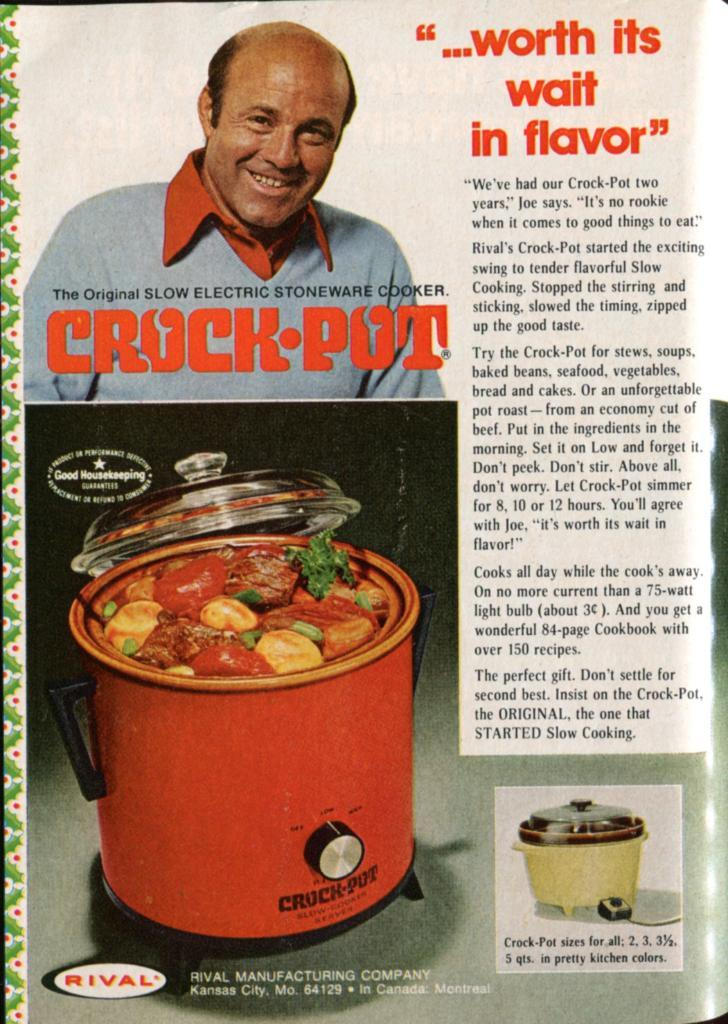Provide a one-sentence caption for the provided image. An old looking magazine ad for the crock pot. 